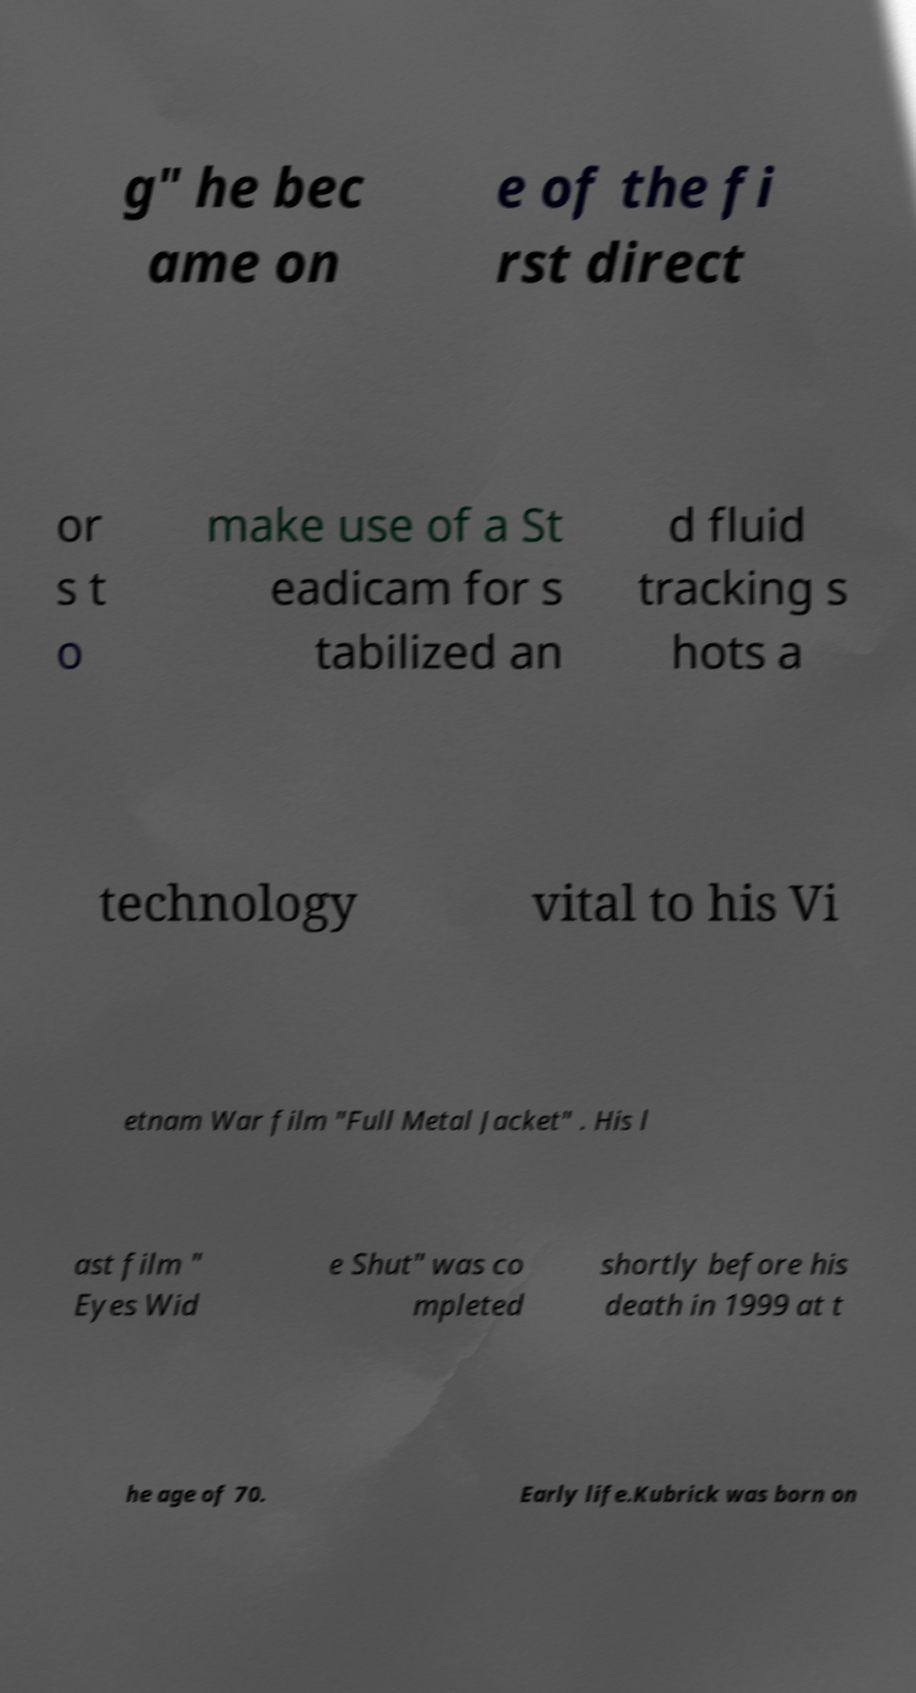Could you assist in decoding the text presented in this image and type it out clearly? g" he bec ame on e of the fi rst direct or s t o make use of a St eadicam for s tabilized an d fluid tracking s hots a technology vital to his Vi etnam War film "Full Metal Jacket" . His l ast film " Eyes Wid e Shut" was co mpleted shortly before his death in 1999 at t he age of 70. Early life.Kubrick was born on 